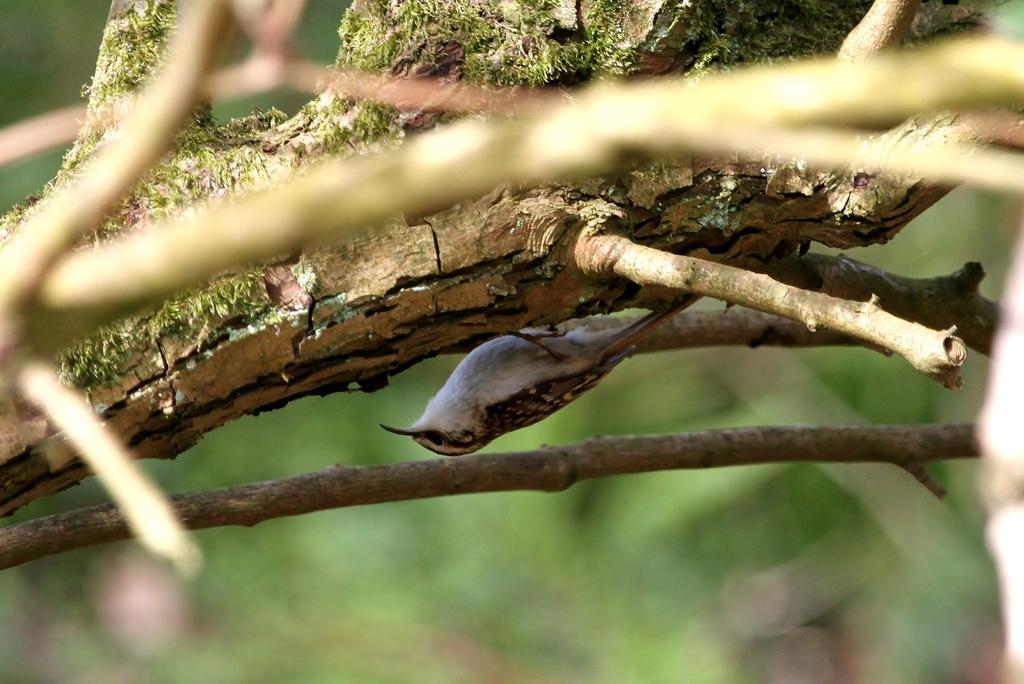Could you give a brief overview of what you see in this image? In this picture we can see a bird on the branch. Behind the bird there is the blurred background. 